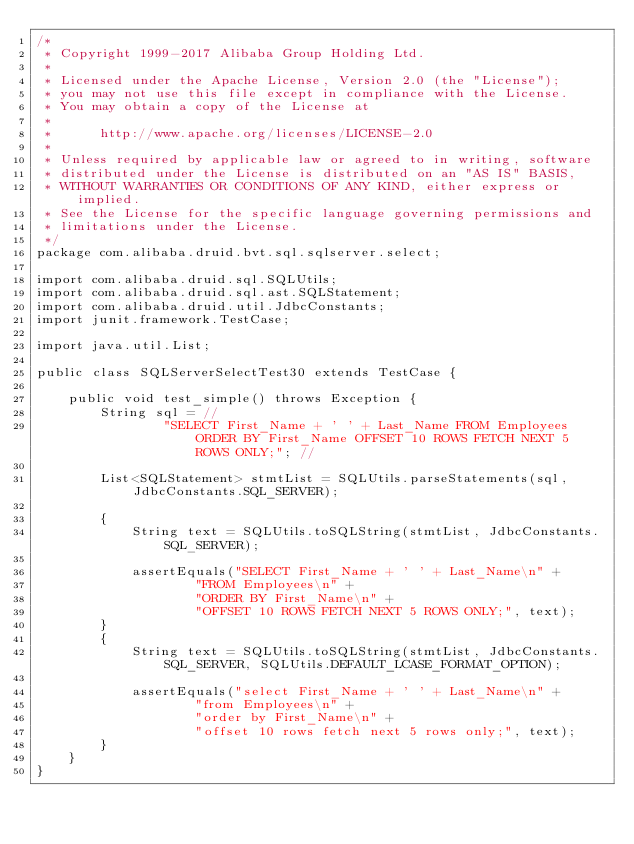Convert code to text. <code><loc_0><loc_0><loc_500><loc_500><_Java_>/*
 * Copyright 1999-2017 Alibaba Group Holding Ltd.
 *
 * Licensed under the Apache License, Version 2.0 (the "License");
 * you may not use this file except in compliance with the License.
 * You may obtain a copy of the License at
 *
 *      http://www.apache.org/licenses/LICENSE-2.0
 *
 * Unless required by applicable law or agreed to in writing, software
 * distributed under the License is distributed on an "AS IS" BASIS,
 * WITHOUT WARRANTIES OR CONDITIONS OF ANY KIND, either express or implied.
 * See the License for the specific language governing permissions and
 * limitations under the License.
 */
package com.alibaba.druid.bvt.sql.sqlserver.select;

import com.alibaba.druid.sql.SQLUtils;
import com.alibaba.druid.sql.ast.SQLStatement;
import com.alibaba.druid.util.JdbcConstants;
import junit.framework.TestCase;

import java.util.List;

public class SQLServerSelectTest30 extends TestCase {

    public void test_simple() throws Exception {
        String sql = //
                "SELECT First_Name + ' ' + Last_Name FROM Employees ORDER BY First_Name OFFSET 10 ROWS FETCH NEXT 5 ROWS ONLY;"; //

        List<SQLStatement> stmtList = SQLUtils.parseStatements(sql, JdbcConstants.SQL_SERVER);

        {
            String text = SQLUtils.toSQLString(stmtList, JdbcConstants.SQL_SERVER);

            assertEquals("SELECT First_Name + ' ' + Last_Name\n" +
                    "FROM Employees\n" +
                    "ORDER BY First_Name\n" +
                    "OFFSET 10 ROWS FETCH NEXT 5 ROWS ONLY;", text);
        }
        {
            String text = SQLUtils.toSQLString(stmtList, JdbcConstants.SQL_SERVER, SQLUtils.DEFAULT_LCASE_FORMAT_OPTION);

            assertEquals("select First_Name + ' ' + Last_Name\n" +
                    "from Employees\n" +
                    "order by First_Name\n" +
                    "offset 10 rows fetch next 5 rows only;", text);
        }
    }
}
</code> 